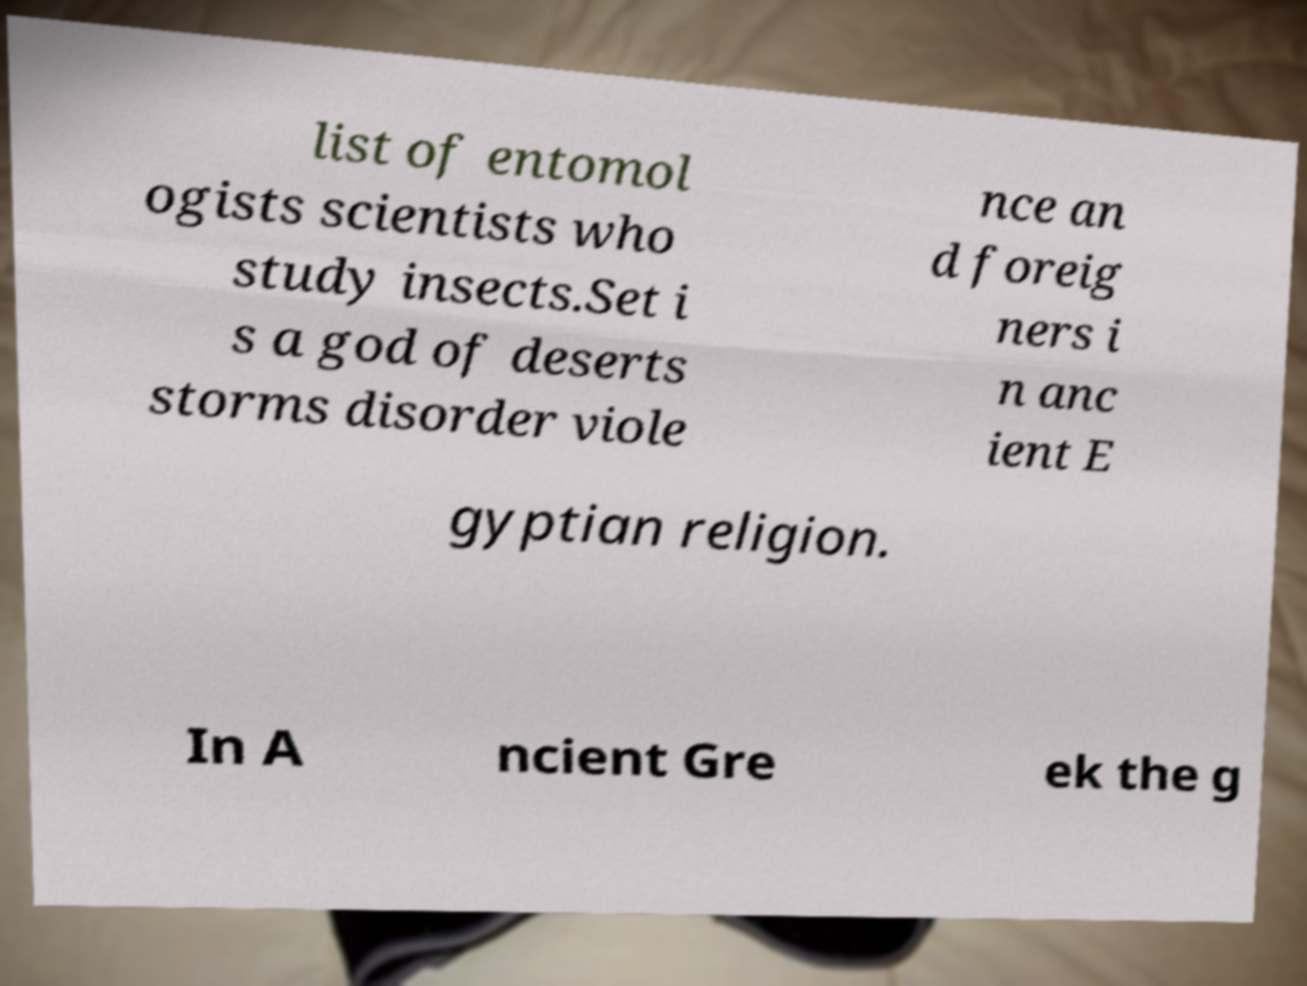Please identify and transcribe the text found in this image. list of entomol ogists scientists who study insects.Set i s a god of deserts storms disorder viole nce an d foreig ners i n anc ient E gyptian religion. In A ncient Gre ek the g 